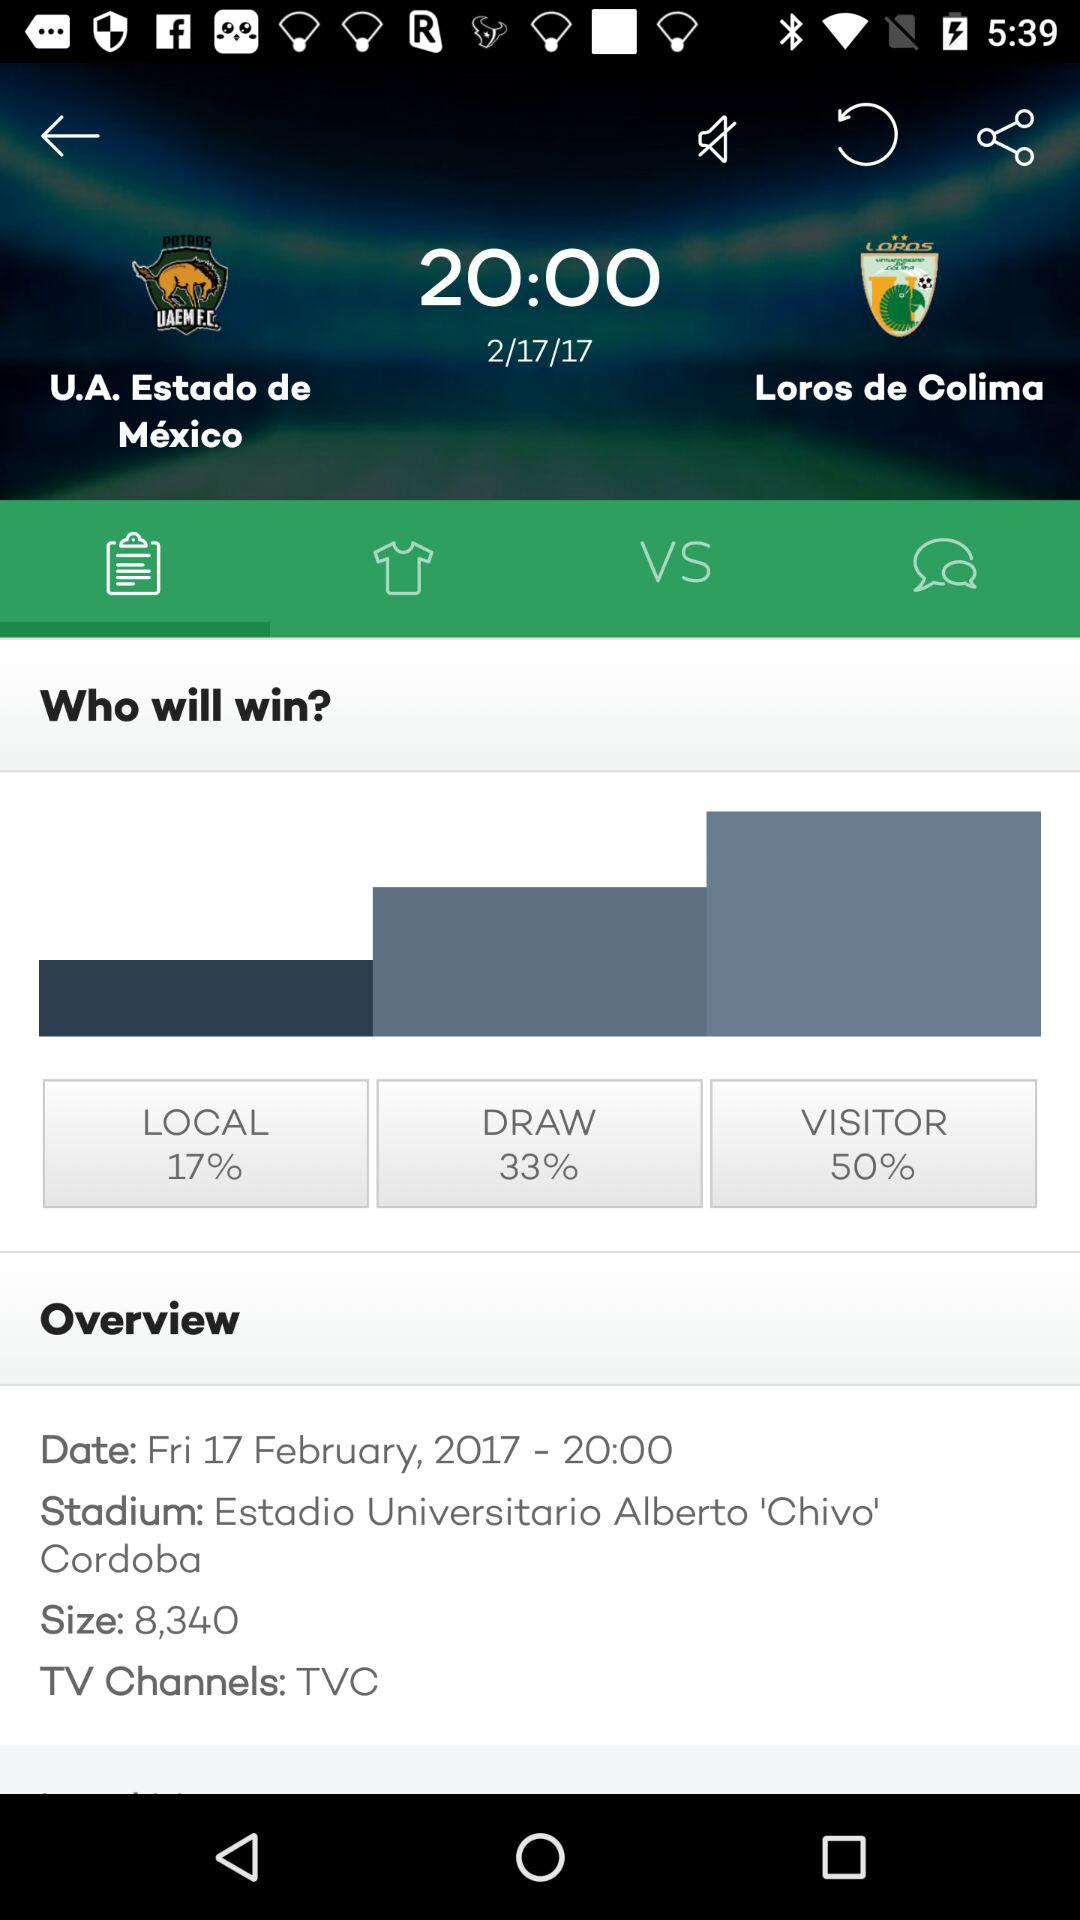What channel will it be broadcast on? It will be broadcast on the TVC channel. 